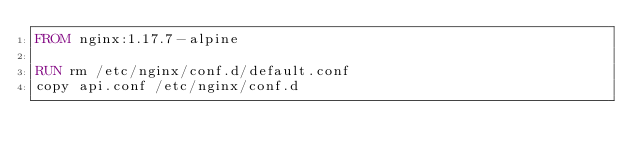Convert code to text. <code><loc_0><loc_0><loc_500><loc_500><_Dockerfile_>FROM nginx:1.17.7-alpine

RUN rm /etc/nginx/conf.d/default.conf
copy api.conf /etc/nginx/conf.d
</code> 